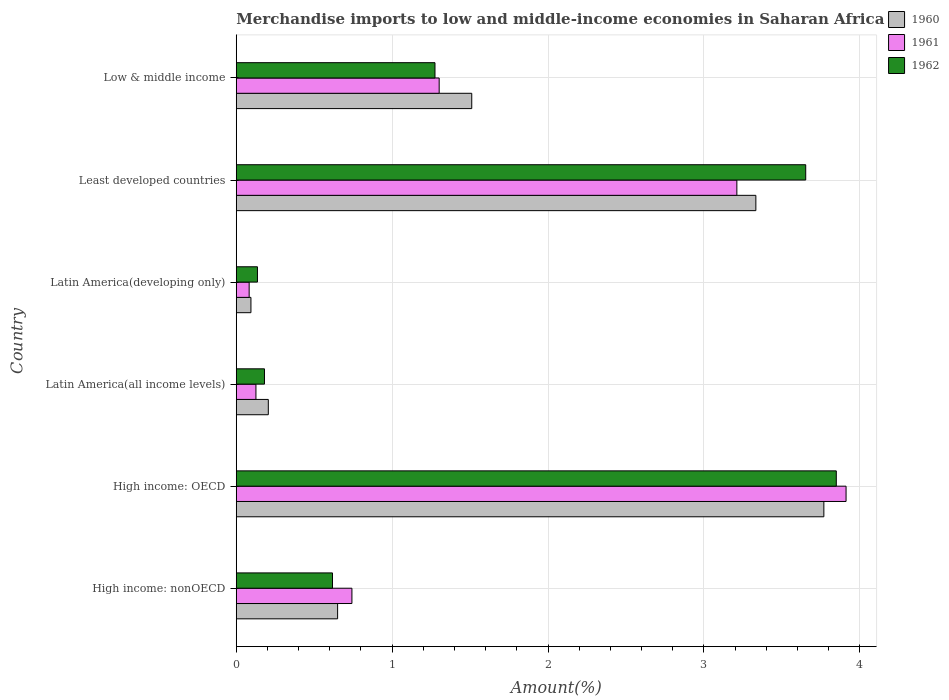How many different coloured bars are there?
Provide a short and direct response. 3. How many groups of bars are there?
Ensure brevity in your answer.  6. Are the number of bars per tick equal to the number of legend labels?
Give a very brief answer. Yes. What is the label of the 2nd group of bars from the top?
Keep it short and to the point. Least developed countries. In how many cases, is the number of bars for a given country not equal to the number of legend labels?
Provide a succinct answer. 0. What is the percentage of amount earned from merchandise imports in 1960 in High income: OECD?
Your answer should be compact. 3.77. Across all countries, what is the maximum percentage of amount earned from merchandise imports in 1962?
Offer a terse response. 3.85. Across all countries, what is the minimum percentage of amount earned from merchandise imports in 1962?
Offer a terse response. 0.14. In which country was the percentage of amount earned from merchandise imports in 1960 maximum?
Ensure brevity in your answer.  High income: OECD. In which country was the percentage of amount earned from merchandise imports in 1962 minimum?
Ensure brevity in your answer.  Latin America(developing only). What is the total percentage of amount earned from merchandise imports in 1962 in the graph?
Give a very brief answer. 9.71. What is the difference between the percentage of amount earned from merchandise imports in 1961 in High income: OECD and that in Low & middle income?
Provide a short and direct response. 2.61. What is the difference between the percentage of amount earned from merchandise imports in 1961 in High income: OECD and the percentage of amount earned from merchandise imports in 1960 in Latin America(all income levels)?
Give a very brief answer. 3.71. What is the average percentage of amount earned from merchandise imports in 1960 per country?
Your response must be concise. 1.59. What is the difference between the percentage of amount earned from merchandise imports in 1960 and percentage of amount earned from merchandise imports in 1961 in High income: OECD?
Offer a very short reply. -0.14. What is the ratio of the percentage of amount earned from merchandise imports in 1962 in Latin America(all income levels) to that in Latin America(developing only)?
Offer a terse response. 1.33. What is the difference between the highest and the second highest percentage of amount earned from merchandise imports in 1961?
Your answer should be very brief. 0.7. What is the difference between the highest and the lowest percentage of amount earned from merchandise imports in 1961?
Make the answer very short. 3.83. In how many countries, is the percentage of amount earned from merchandise imports in 1962 greater than the average percentage of amount earned from merchandise imports in 1962 taken over all countries?
Provide a succinct answer. 2. Is the sum of the percentage of amount earned from merchandise imports in 1960 in High income: OECD and Least developed countries greater than the maximum percentage of amount earned from merchandise imports in 1962 across all countries?
Provide a succinct answer. Yes. Is it the case that in every country, the sum of the percentage of amount earned from merchandise imports in 1960 and percentage of amount earned from merchandise imports in 1961 is greater than the percentage of amount earned from merchandise imports in 1962?
Your response must be concise. Yes. What is the difference between two consecutive major ticks on the X-axis?
Provide a short and direct response. 1. Are the values on the major ticks of X-axis written in scientific E-notation?
Offer a terse response. No. Does the graph contain any zero values?
Give a very brief answer. No. Where does the legend appear in the graph?
Provide a short and direct response. Top right. How many legend labels are there?
Give a very brief answer. 3. How are the legend labels stacked?
Provide a short and direct response. Vertical. What is the title of the graph?
Keep it short and to the point. Merchandise imports to low and middle-income economies in Saharan Africa. What is the label or title of the X-axis?
Offer a very short reply. Amount(%). What is the Amount(%) of 1960 in High income: nonOECD?
Your answer should be compact. 0.65. What is the Amount(%) in 1961 in High income: nonOECD?
Provide a short and direct response. 0.74. What is the Amount(%) of 1962 in High income: nonOECD?
Your answer should be compact. 0.62. What is the Amount(%) in 1960 in High income: OECD?
Ensure brevity in your answer.  3.77. What is the Amount(%) of 1961 in High income: OECD?
Offer a very short reply. 3.91. What is the Amount(%) in 1962 in High income: OECD?
Make the answer very short. 3.85. What is the Amount(%) of 1960 in Latin America(all income levels)?
Keep it short and to the point. 0.21. What is the Amount(%) of 1961 in Latin America(all income levels)?
Offer a terse response. 0.13. What is the Amount(%) in 1962 in Latin America(all income levels)?
Provide a succinct answer. 0.18. What is the Amount(%) of 1960 in Latin America(developing only)?
Your answer should be compact. 0.09. What is the Amount(%) of 1961 in Latin America(developing only)?
Your answer should be compact. 0.08. What is the Amount(%) of 1962 in Latin America(developing only)?
Provide a short and direct response. 0.14. What is the Amount(%) of 1960 in Least developed countries?
Provide a succinct answer. 3.33. What is the Amount(%) of 1961 in Least developed countries?
Your answer should be compact. 3.21. What is the Amount(%) of 1962 in Least developed countries?
Give a very brief answer. 3.65. What is the Amount(%) in 1960 in Low & middle income?
Make the answer very short. 1.51. What is the Amount(%) of 1961 in Low & middle income?
Give a very brief answer. 1.3. What is the Amount(%) of 1962 in Low & middle income?
Make the answer very short. 1.27. Across all countries, what is the maximum Amount(%) in 1960?
Offer a terse response. 3.77. Across all countries, what is the maximum Amount(%) in 1961?
Keep it short and to the point. 3.91. Across all countries, what is the maximum Amount(%) of 1962?
Give a very brief answer. 3.85. Across all countries, what is the minimum Amount(%) in 1960?
Offer a terse response. 0.09. Across all countries, what is the minimum Amount(%) in 1961?
Provide a succinct answer. 0.08. Across all countries, what is the minimum Amount(%) of 1962?
Offer a very short reply. 0.14. What is the total Amount(%) of 1960 in the graph?
Provide a succinct answer. 9.56. What is the total Amount(%) of 1961 in the graph?
Your answer should be compact. 9.38. What is the total Amount(%) of 1962 in the graph?
Provide a short and direct response. 9.71. What is the difference between the Amount(%) of 1960 in High income: nonOECD and that in High income: OECD?
Your response must be concise. -3.12. What is the difference between the Amount(%) of 1961 in High income: nonOECD and that in High income: OECD?
Offer a very short reply. -3.17. What is the difference between the Amount(%) of 1962 in High income: nonOECD and that in High income: OECD?
Give a very brief answer. -3.23. What is the difference between the Amount(%) in 1960 in High income: nonOECD and that in Latin America(all income levels)?
Your answer should be compact. 0.44. What is the difference between the Amount(%) in 1961 in High income: nonOECD and that in Latin America(all income levels)?
Your response must be concise. 0.62. What is the difference between the Amount(%) in 1962 in High income: nonOECD and that in Latin America(all income levels)?
Make the answer very short. 0.44. What is the difference between the Amount(%) of 1960 in High income: nonOECD and that in Latin America(developing only)?
Your response must be concise. 0.56. What is the difference between the Amount(%) in 1961 in High income: nonOECD and that in Latin America(developing only)?
Give a very brief answer. 0.66. What is the difference between the Amount(%) in 1962 in High income: nonOECD and that in Latin America(developing only)?
Give a very brief answer. 0.48. What is the difference between the Amount(%) of 1960 in High income: nonOECD and that in Least developed countries?
Make the answer very short. -2.68. What is the difference between the Amount(%) in 1961 in High income: nonOECD and that in Least developed countries?
Your answer should be compact. -2.47. What is the difference between the Amount(%) in 1962 in High income: nonOECD and that in Least developed countries?
Your response must be concise. -3.04. What is the difference between the Amount(%) of 1960 in High income: nonOECD and that in Low & middle income?
Make the answer very short. -0.86. What is the difference between the Amount(%) in 1961 in High income: nonOECD and that in Low & middle income?
Provide a succinct answer. -0.56. What is the difference between the Amount(%) of 1962 in High income: nonOECD and that in Low & middle income?
Provide a short and direct response. -0.66. What is the difference between the Amount(%) in 1960 in High income: OECD and that in Latin America(all income levels)?
Provide a succinct answer. 3.56. What is the difference between the Amount(%) in 1961 in High income: OECD and that in Latin America(all income levels)?
Offer a very short reply. 3.79. What is the difference between the Amount(%) of 1962 in High income: OECD and that in Latin America(all income levels)?
Provide a short and direct response. 3.67. What is the difference between the Amount(%) in 1960 in High income: OECD and that in Latin America(developing only)?
Keep it short and to the point. 3.68. What is the difference between the Amount(%) in 1961 in High income: OECD and that in Latin America(developing only)?
Give a very brief answer. 3.83. What is the difference between the Amount(%) in 1962 in High income: OECD and that in Latin America(developing only)?
Make the answer very short. 3.71. What is the difference between the Amount(%) in 1960 in High income: OECD and that in Least developed countries?
Your answer should be very brief. 0.44. What is the difference between the Amount(%) of 1961 in High income: OECD and that in Least developed countries?
Give a very brief answer. 0.7. What is the difference between the Amount(%) in 1962 in High income: OECD and that in Least developed countries?
Your answer should be very brief. 0.2. What is the difference between the Amount(%) in 1960 in High income: OECD and that in Low & middle income?
Offer a terse response. 2.26. What is the difference between the Amount(%) of 1961 in High income: OECD and that in Low & middle income?
Provide a short and direct response. 2.61. What is the difference between the Amount(%) in 1962 in High income: OECD and that in Low & middle income?
Offer a terse response. 2.57. What is the difference between the Amount(%) of 1960 in Latin America(all income levels) and that in Latin America(developing only)?
Keep it short and to the point. 0.11. What is the difference between the Amount(%) in 1961 in Latin America(all income levels) and that in Latin America(developing only)?
Your answer should be compact. 0.04. What is the difference between the Amount(%) of 1962 in Latin America(all income levels) and that in Latin America(developing only)?
Offer a very short reply. 0.05. What is the difference between the Amount(%) of 1960 in Latin America(all income levels) and that in Least developed countries?
Provide a succinct answer. -3.13. What is the difference between the Amount(%) of 1961 in Latin America(all income levels) and that in Least developed countries?
Your answer should be very brief. -3.08. What is the difference between the Amount(%) of 1962 in Latin America(all income levels) and that in Least developed countries?
Provide a succinct answer. -3.47. What is the difference between the Amount(%) of 1960 in Latin America(all income levels) and that in Low & middle income?
Your response must be concise. -1.3. What is the difference between the Amount(%) of 1961 in Latin America(all income levels) and that in Low & middle income?
Give a very brief answer. -1.18. What is the difference between the Amount(%) in 1962 in Latin America(all income levels) and that in Low & middle income?
Make the answer very short. -1.09. What is the difference between the Amount(%) in 1960 in Latin America(developing only) and that in Least developed countries?
Your answer should be compact. -3.24. What is the difference between the Amount(%) of 1961 in Latin America(developing only) and that in Least developed countries?
Give a very brief answer. -3.13. What is the difference between the Amount(%) of 1962 in Latin America(developing only) and that in Least developed countries?
Offer a terse response. -3.52. What is the difference between the Amount(%) of 1960 in Latin America(developing only) and that in Low & middle income?
Your answer should be very brief. -1.42. What is the difference between the Amount(%) of 1961 in Latin America(developing only) and that in Low & middle income?
Make the answer very short. -1.22. What is the difference between the Amount(%) of 1962 in Latin America(developing only) and that in Low & middle income?
Keep it short and to the point. -1.14. What is the difference between the Amount(%) of 1960 in Least developed countries and that in Low & middle income?
Give a very brief answer. 1.82. What is the difference between the Amount(%) in 1961 in Least developed countries and that in Low & middle income?
Your response must be concise. 1.91. What is the difference between the Amount(%) of 1962 in Least developed countries and that in Low & middle income?
Offer a very short reply. 2.38. What is the difference between the Amount(%) in 1960 in High income: nonOECD and the Amount(%) in 1961 in High income: OECD?
Provide a succinct answer. -3.26. What is the difference between the Amount(%) in 1960 in High income: nonOECD and the Amount(%) in 1962 in High income: OECD?
Ensure brevity in your answer.  -3.2. What is the difference between the Amount(%) in 1961 in High income: nonOECD and the Amount(%) in 1962 in High income: OECD?
Your response must be concise. -3.11. What is the difference between the Amount(%) of 1960 in High income: nonOECD and the Amount(%) of 1961 in Latin America(all income levels)?
Keep it short and to the point. 0.52. What is the difference between the Amount(%) of 1960 in High income: nonOECD and the Amount(%) of 1962 in Latin America(all income levels)?
Offer a terse response. 0.47. What is the difference between the Amount(%) in 1961 in High income: nonOECD and the Amount(%) in 1962 in Latin America(all income levels)?
Offer a very short reply. 0.56. What is the difference between the Amount(%) in 1960 in High income: nonOECD and the Amount(%) in 1961 in Latin America(developing only)?
Your answer should be very brief. 0.57. What is the difference between the Amount(%) of 1960 in High income: nonOECD and the Amount(%) of 1962 in Latin America(developing only)?
Provide a short and direct response. 0.51. What is the difference between the Amount(%) in 1961 in High income: nonOECD and the Amount(%) in 1962 in Latin America(developing only)?
Provide a short and direct response. 0.61. What is the difference between the Amount(%) in 1960 in High income: nonOECD and the Amount(%) in 1961 in Least developed countries?
Provide a short and direct response. -2.56. What is the difference between the Amount(%) in 1960 in High income: nonOECD and the Amount(%) in 1962 in Least developed countries?
Give a very brief answer. -3. What is the difference between the Amount(%) in 1961 in High income: nonOECD and the Amount(%) in 1962 in Least developed countries?
Ensure brevity in your answer.  -2.91. What is the difference between the Amount(%) of 1960 in High income: nonOECD and the Amount(%) of 1961 in Low & middle income?
Ensure brevity in your answer.  -0.65. What is the difference between the Amount(%) in 1960 in High income: nonOECD and the Amount(%) in 1962 in Low & middle income?
Your response must be concise. -0.62. What is the difference between the Amount(%) of 1961 in High income: nonOECD and the Amount(%) of 1962 in Low & middle income?
Keep it short and to the point. -0.53. What is the difference between the Amount(%) in 1960 in High income: OECD and the Amount(%) in 1961 in Latin America(all income levels)?
Your response must be concise. 3.64. What is the difference between the Amount(%) in 1960 in High income: OECD and the Amount(%) in 1962 in Latin America(all income levels)?
Your answer should be very brief. 3.59. What is the difference between the Amount(%) in 1961 in High income: OECD and the Amount(%) in 1962 in Latin America(all income levels)?
Your answer should be very brief. 3.73. What is the difference between the Amount(%) of 1960 in High income: OECD and the Amount(%) of 1961 in Latin America(developing only)?
Offer a very short reply. 3.69. What is the difference between the Amount(%) in 1960 in High income: OECD and the Amount(%) in 1962 in Latin America(developing only)?
Ensure brevity in your answer.  3.63. What is the difference between the Amount(%) of 1961 in High income: OECD and the Amount(%) of 1962 in Latin America(developing only)?
Make the answer very short. 3.78. What is the difference between the Amount(%) of 1960 in High income: OECD and the Amount(%) of 1961 in Least developed countries?
Your answer should be compact. 0.56. What is the difference between the Amount(%) of 1960 in High income: OECD and the Amount(%) of 1962 in Least developed countries?
Keep it short and to the point. 0.12. What is the difference between the Amount(%) of 1961 in High income: OECD and the Amount(%) of 1962 in Least developed countries?
Make the answer very short. 0.26. What is the difference between the Amount(%) of 1960 in High income: OECD and the Amount(%) of 1961 in Low & middle income?
Ensure brevity in your answer.  2.47. What is the difference between the Amount(%) in 1960 in High income: OECD and the Amount(%) in 1962 in Low & middle income?
Your answer should be compact. 2.49. What is the difference between the Amount(%) in 1961 in High income: OECD and the Amount(%) in 1962 in Low & middle income?
Provide a short and direct response. 2.64. What is the difference between the Amount(%) in 1960 in Latin America(all income levels) and the Amount(%) in 1961 in Latin America(developing only)?
Give a very brief answer. 0.12. What is the difference between the Amount(%) of 1960 in Latin America(all income levels) and the Amount(%) of 1962 in Latin America(developing only)?
Your answer should be very brief. 0.07. What is the difference between the Amount(%) in 1961 in Latin America(all income levels) and the Amount(%) in 1962 in Latin America(developing only)?
Provide a succinct answer. -0.01. What is the difference between the Amount(%) of 1960 in Latin America(all income levels) and the Amount(%) of 1961 in Least developed countries?
Your answer should be compact. -3.01. What is the difference between the Amount(%) in 1960 in Latin America(all income levels) and the Amount(%) in 1962 in Least developed countries?
Provide a short and direct response. -3.45. What is the difference between the Amount(%) in 1961 in Latin America(all income levels) and the Amount(%) in 1962 in Least developed countries?
Ensure brevity in your answer.  -3.53. What is the difference between the Amount(%) in 1960 in Latin America(all income levels) and the Amount(%) in 1961 in Low & middle income?
Give a very brief answer. -1.1. What is the difference between the Amount(%) of 1960 in Latin America(all income levels) and the Amount(%) of 1962 in Low & middle income?
Give a very brief answer. -1.07. What is the difference between the Amount(%) of 1961 in Latin America(all income levels) and the Amount(%) of 1962 in Low & middle income?
Your answer should be very brief. -1.15. What is the difference between the Amount(%) in 1960 in Latin America(developing only) and the Amount(%) in 1961 in Least developed countries?
Your answer should be very brief. -3.12. What is the difference between the Amount(%) of 1960 in Latin America(developing only) and the Amount(%) of 1962 in Least developed countries?
Give a very brief answer. -3.56. What is the difference between the Amount(%) of 1961 in Latin America(developing only) and the Amount(%) of 1962 in Least developed countries?
Your answer should be compact. -3.57. What is the difference between the Amount(%) in 1960 in Latin America(developing only) and the Amount(%) in 1961 in Low & middle income?
Offer a very short reply. -1.21. What is the difference between the Amount(%) of 1960 in Latin America(developing only) and the Amount(%) of 1962 in Low & middle income?
Offer a very short reply. -1.18. What is the difference between the Amount(%) in 1961 in Latin America(developing only) and the Amount(%) in 1962 in Low & middle income?
Offer a very short reply. -1.19. What is the difference between the Amount(%) in 1960 in Least developed countries and the Amount(%) in 1961 in Low & middle income?
Ensure brevity in your answer.  2.03. What is the difference between the Amount(%) of 1960 in Least developed countries and the Amount(%) of 1962 in Low & middle income?
Offer a terse response. 2.06. What is the difference between the Amount(%) in 1961 in Least developed countries and the Amount(%) in 1962 in Low & middle income?
Offer a very short reply. 1.94. What is the average Amount(%) of 1960 per country?
Your response must be concise. 1.59. What is the average Amount(%) in 1961 per country?
Your answer should be compact. 1.56. What is the average Amount(%) of 1962 per country?
Ensure brevity in your answer.  1.62. What is the difference between the Amount(%) of 1960 and Amount(%) of 1961 in High income: nonOECD?
Ensure brevity in your answer.  -0.09. What is the difference between the Amount(%) in 1960 and Amount(%) in 1962 in High income: nonOECD?
Give a very brief answer. 0.03. What is the difference between the Amount(%) of 1961 and Amount(%) of 1962 in High income: nonOECD?
Give a very brief answer. 0.12. What is the difference between the Amount(%) in 1960 and Amount(%) in 1961 in High income: OECD?
Your response must be concise. -0.14. What is the difference between the Amount(%) of 1960 and Amount(%) of 1962 in High income: OECD?
Your response must be concise. -0.08. What is the difference between the Amount(%) of 1961 and Amount(%) of 1962 in High income: OECD?
Make the answer very short. 0.06. What is the difference between the Amount(%) in 1960 and Amount(%) in 1961 in Latin America(all income levels)?
Your answer should be compact. 0.08. What is the difference between the Amount(%) in 1960 and Amount(%) in 1962 in Latin America(all income levels)?
Your answer should be compact. 0.02. What is the difference between the Amount(%) of 1961 and Amount(%) of 1962 in Latin America(all income levels)?
Provide a short and direct response. -0.05. What is the difference between the Amount(%) of 1960 and Amount(%) of 1961 in Latin America(developing only)?
Your answer should be very brief. 0.01. What is the difference between the Amount(%) of 1960 and Amount(%) of 1962 in Latin America(developing only)?
Your answer should be compact. -0.04. What is the difference between the Amount(%) of 1961 and Amount(%) of 1962 in Latin America(developing only)?
Provide a short and direct response. -0.05. What is the difference between the Amount(%) of 1960 and Amount(%) of 1961 in Least developed countries?
Your answer should be very brief. 0.12. What is the difference between the Amount(%) in 1960 and Amount(%) in 1962 in Least developed countries?
Your answer should be very brief. -0.32. What is the difference between the Amount(%) of 1961 and Amount(%) of 1962 in Least developed countries?
Keep it short and to the point. -0.44. What is the difference between the Amount(%) in 1960 and Amount(%) in 1961 in Low & middle income?
Provide a short and direct response. 0.21. What is the difference between the Amount(%) in 1960 and Amount(%) in 1962 in Low & middle income?
Offer a terse response. 0.24. What is the difference between the Amount(%) in 1961 and Amount(%) in 1962 in Low & middle income?
Offer a very short reply. 0.03. What is the ratio of the Amount(%) of 1960 in High income: nonOECD to that in High income: OECD?
Your response must be concise. 0.17. What is the ratio of the Amount(%) of 1961 in High income: nonOECD to that in High income: OECD?
Offer a very short reply. 0.19. What is the ratio of the Amount(%) in 1962 in High income: nonOECD to that in High income: OECD?
Provide a succinct answer. 0.16. What is the ratio of the Amount(%) of 1960 in High income: nonOECD to that in Latin America(all income levels)?
Provide a short and direct response. 3.16. What is the ratio of the Amount(%) in 1961 in High income: nonOECD to that in Latin America(all income levels)?
Your answer should be very brief. 5.88. What is the ratio of the Amount(%) of 1962 in High income: nonOECD to that in Latin America(all income levels)?
Provide a short and direct response. 3.41. What is the ratio of the Amount(%) of 1960 in High income: nonOECD to that in Latin America(developing only)?
Offer a terse response. 6.9. What is the ratio of the Amount(%) in 1961 in High income: nonOECD to that in Latin America(developing only)?
Your response must be concise. 8.96. What is the ratio of the Amount(%) of 1962 in High income: nonOECD to that in Latin America(developing only)?
Provide a succinct answer. 4.54. What is the ratio of the Amount(%) of 1960 in High income: nonOECD to that in Least developed countries?
Your answer should be very brief. 0.2. What is the ratio of the Amount(%) of 1961 in High income: nonOECD to that in Least developed countries?
Keep it short and to the point. 0.23. What is the ratio of the Amount(%) of 1962 in High income: nonOECD to that in Least developed countries?
Your answer should be very brief. 0.17. What is the ratio of the Amount(%) of 1960 in High income: nonOECD to that in Low & middle income?
Keep it short and to the point. 0.43. What is the ratio of the Amount(%) in 1961 in High income: nonOECD to that in Low & middle income?
Make the answer very short. 0.57. What is the ratio of the Amount(%) of 1962 in High income: nonOECD to that in Low & middle income?
Make the answer very short. 0.48. What is the ratio of the Amount(%) of 1960 in High income: OECD to that in Latin America(all income levels)?
Ensure brevity in your answer.  18.33. What is the ratio of the Amount(%) in 1961 in High income: OECD to that in Latin America(all income levels)?
Keep it short and to the point. 30.99. What is the ratio of the Amount(%) of 1962 in High income: OECD to that in Latin America(all income levels)?
Your answer should be compact. 21.26. What is the ratio of the Amount(%) in 1960 in High income: OECD to that in Latin America(developing only)?
Ensure brevity in your answer.  40. What is the ratio of the Amount(%) in 1961 in High income: OECD to that in Latin America(developing only)?
Make the answer very short. 47.27. What is the ratio of the Amount(%) of 1962 in High income: OECD to that in Latin America(developing only)?
Your response must be concise. 28.31. What is the ratio of the Amount(%) of 1960 in High income: OECD to that in Least developed countries?
Ensure brevity in your answer.  1.13. What is the ratio of the Amount(%) of 1961 in High income: OECD to that in Least developed countries?
Your response must be concise. 1.22. What is the ratio of the Amount(%) in 1962 in High income: OECD to that in Least developed countries?
Make the answer very short. 1.05. What is the ratio of the Amount(%) in 1960 in High income: OECD to that in Low & middle income?
Provide a short and direct response. 2.5. What is the ratio of the Amount(%) of 1961 in High income: OECD to that in Low & middle income?
Offer a very short reply. 3.01. What is the ratio of the Amount(%) of 1962 in High income: OECD to that in Low & middle income?
Offer a terse response. 3.02. What is the ratio of the Amount(%) of 1960 in Latin America(all income levels) to that in Latin America(developing only)?
Make the answer very short. 2.18. What is the ratio of the Amount(%) of 1961 in Latin America(all income levels) to that in Latin America(developing only)?
Ensure brevity in your answer.  1.53. What is the ratio of the Amount(%) of 1962 in Latin America(all income levels) to that in Latin America(developing only)?
Make the answer very short. 1.33. What is the ratio of the Amount(%) in 1960 in Latin America(all income levels) to that in Least developed countries?
Give a very brief answer. 0.06. What is the ratio of the Amount(%) of 1961 in Latin America(all income levels) to that in Least developed countries?
Provide a short and direct response. 0.04. What is the ratio of the Amount(%) of 1962 in Latin America(all income levels) to that in Least developed countries?
Your answer should be compact. 0.05. What is the ratio of the Amount(%) in 1960 in Latin America(all income levels) to that in Low & middle income?
Offer a terse response. 0.14. What is the ratio of the Amount(%) of 1961 in Latin America(all income levels) to that in Low & middle income?
Offer a terse response. 0.1. What is the ratio of the Amount(%) of 1962 in Latin America(all income levels) to that in Low & middle income?
Offer a very short reply. 0.14. What is the ratio of the Amount(%) in 1960 in Latin America(developing only) to that in Least developed countries?
Offer a very short reply. 0.03. What is the ratio of the Amount(%) of 1961 in Latin America(developing only) to that in Least developed countries?
Give a very brief answer. 0.03. What is the ratio of the Amount(%) of 1962 in Latin America(developing only) to that in Least developed countries?
Ensure brevity in your answer.  0.04. What is the ratio of the Amount(%) of 1960 in Latin America(developing only) to that in Low & middle income?
Offer a very short reply. 0.06. What is the ratio of the Amount(%) in 1961 in Latin America(developing only) to that in Low & middle income?
Ensure brevity in your answer.  0.06. What is the ratio of the Amount(%) of 1962 in Latin America(developing only) to that in Low & middle income?
Offer a terse response. 0.11. What is the ratio of the Amount(%) in 1960 in Least developed countries to that in Low & middle income?
Provide a succinct answer. 2.21. What is the ratio of the Amount(%) in 1961 in Least developed countries to that in Low & middle income?
Make the answer very short. 2.47. What is the ratio of the Amount(%) of 1962 in Least developed countries to that in Low & middle income?
Offer a terse response. 2.87. What is the difference between the highest and the second highest Amount(%) in 1960?
Your answer should be very brief. 0.44. What is the difference between the highest and the second highest Amount(%) in 1961?
Provide a short and direct response. 0.7. What is the difference between the highest and the second highest Amount(%) of 1962?
Keep it short and to the point. 0.2. What is the difference between the highest and the lowest Amount(%) in 1960?
Give a very brief answer. 3.68. What is the difference between the highest and the lowest Amount(%) of 1961?
Provide a succinct answer. 3.83. What is the difference between the highest and the lowest Amount(%) of 1962?
Ensure brevity in your answer.  3.71. 